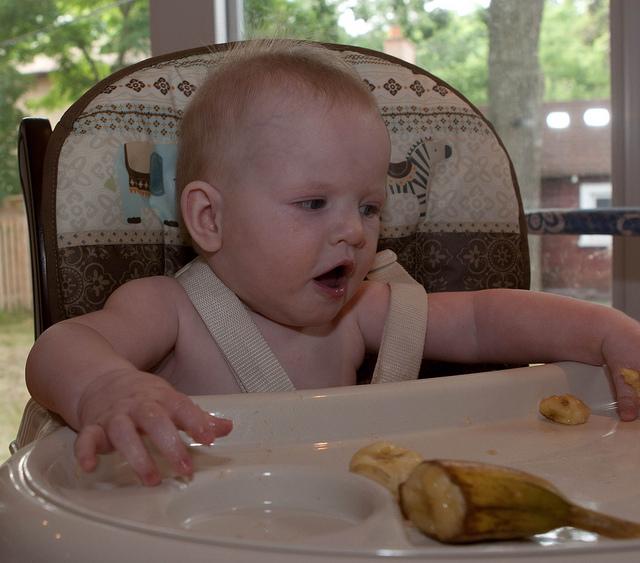Is the baby wearing any dress?
Short answer required. No. Is the baby a messy eater?
Be succinct. Yes. What is the baby trying to eat?
Be succinct. Banana. 